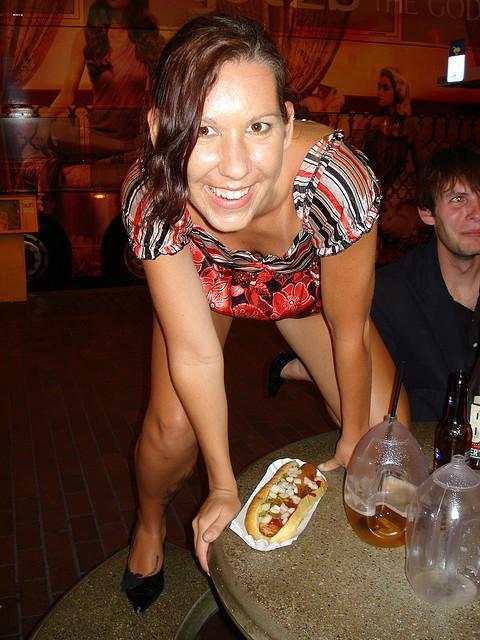How many people are in the picture?
Give a very brief answer. 3. How many bottles are there?
Give a very brief answer. 2. How many cars are to the right?
Give a very brief answer. 0. 